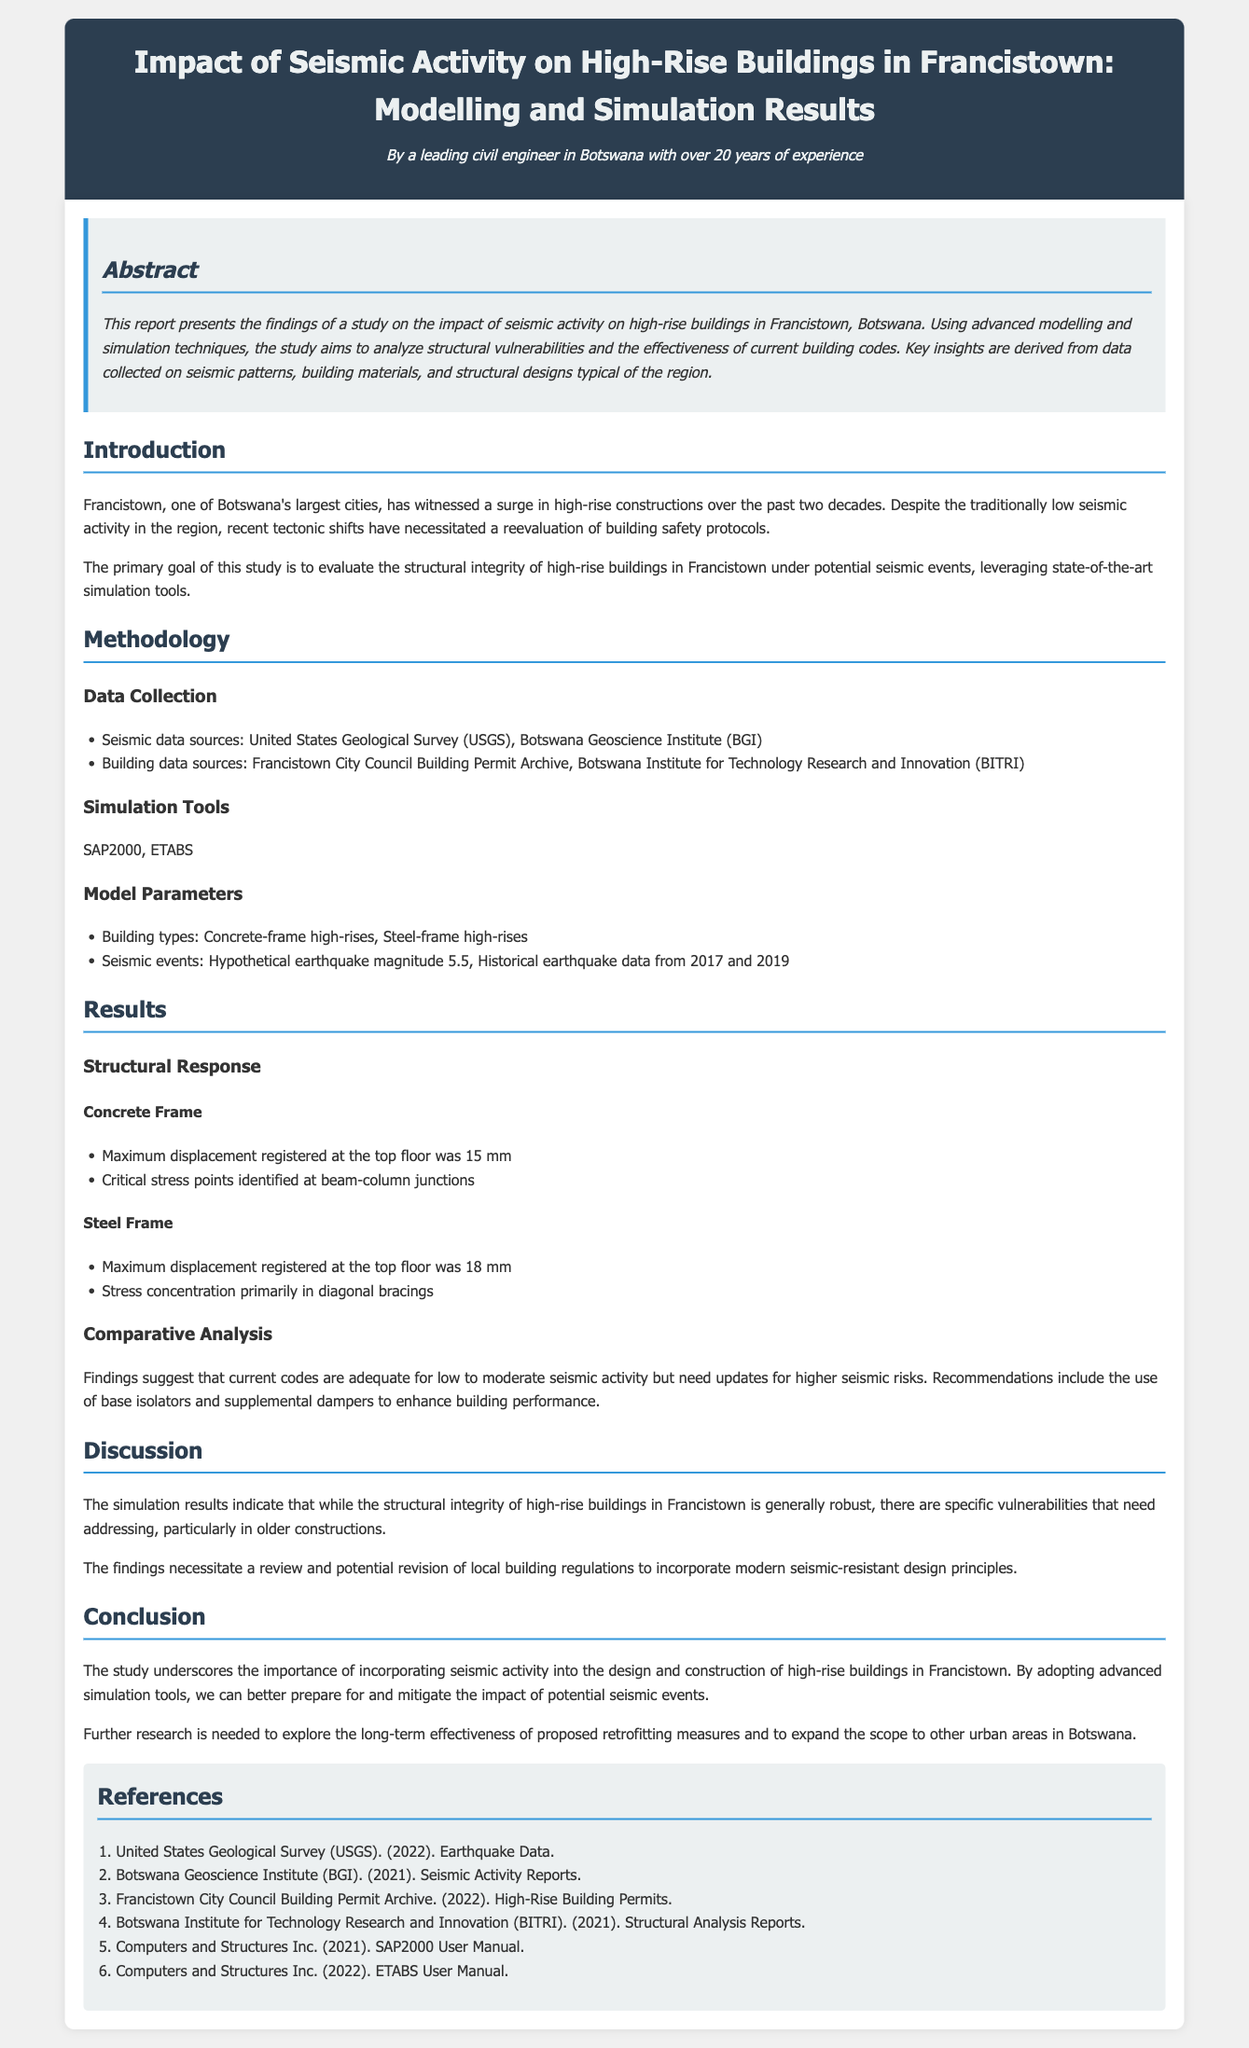What is the main focus of the report? The report focuses on the impact of seismic activity on high-rise buildings in Francistown, Botswana through modelling and simulation results.
Answer: Impact of seismic activity on high-rise buildings in Francistown Which simulation tools were used in the study? The study utilized simulation tools SAP2000 and ETABS for analysis.
Answer: SAP2000, ETABS What was the maximum displacement recorded for concrete frame buildings? The maximum displacement recorded was 15 mm for concrete frame buildings.
Answer: 15 mm What is a key recommendation from the results? A recommendation from the results is to use base isolators and supplemental dampers to enhance building performance.
Answer: Use of base isolators and supplemental dampers What seismic event magnitude was considered in the study? The study considered a hypothetical earthquake with a magnitude of 5.5 for the analysis.
Answer: Magnitude 5.5 Which building material had a higher maximum displacement? The steel frame buildings had a higher maximum displacement compared to concrete frame buildings, registering 18 mm.
Answer: Steel frame What critical stress points were identified in the concrete frame analysis? The critical stress points identified were at beam-column junctions in the concrete frame analysis.
Answer: Beam-column junctions What was the overall conclusion regarding building safety in Francistown? The overall conclusion emphasizes the importance of incorporating seismic activity into the design and construction of high-rise buildings.
Answer: Importance of incorporating seismic activity Which organization provides seismic data as mentioned in the report? The United States Geological Survey (USGS) is one of the organizations that provides seismic data.
Answer: United States Geological Survey (USGS) 